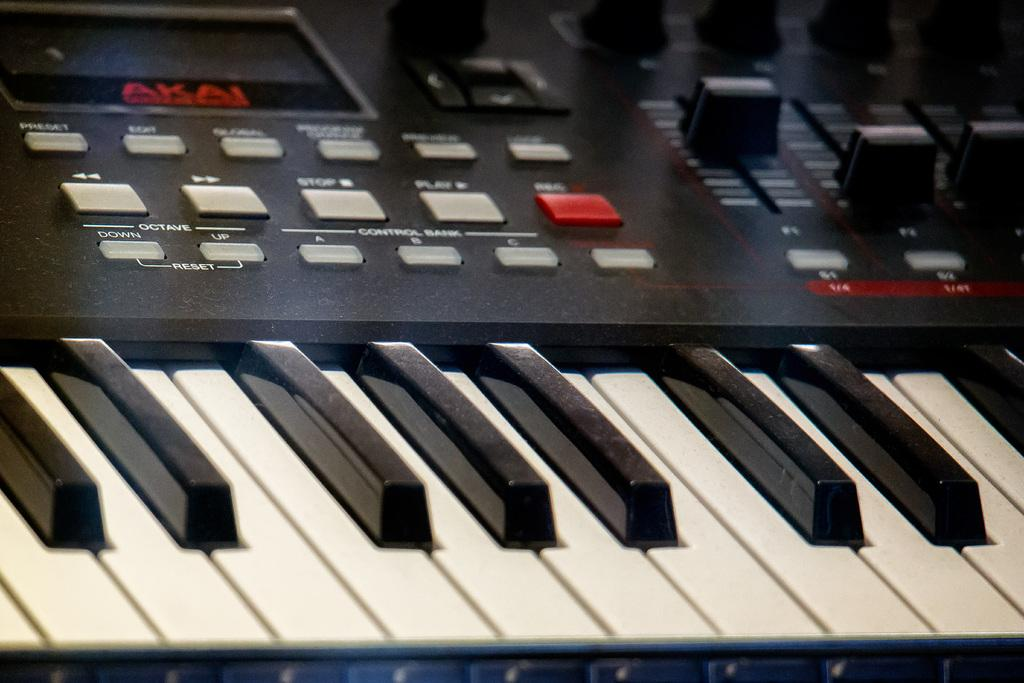<image>
Relay a brief, clear account of the picture shown. A KEYBOARD THAT IS MADE BY AKAI THAT IS BLACK, WHITE AND RED 